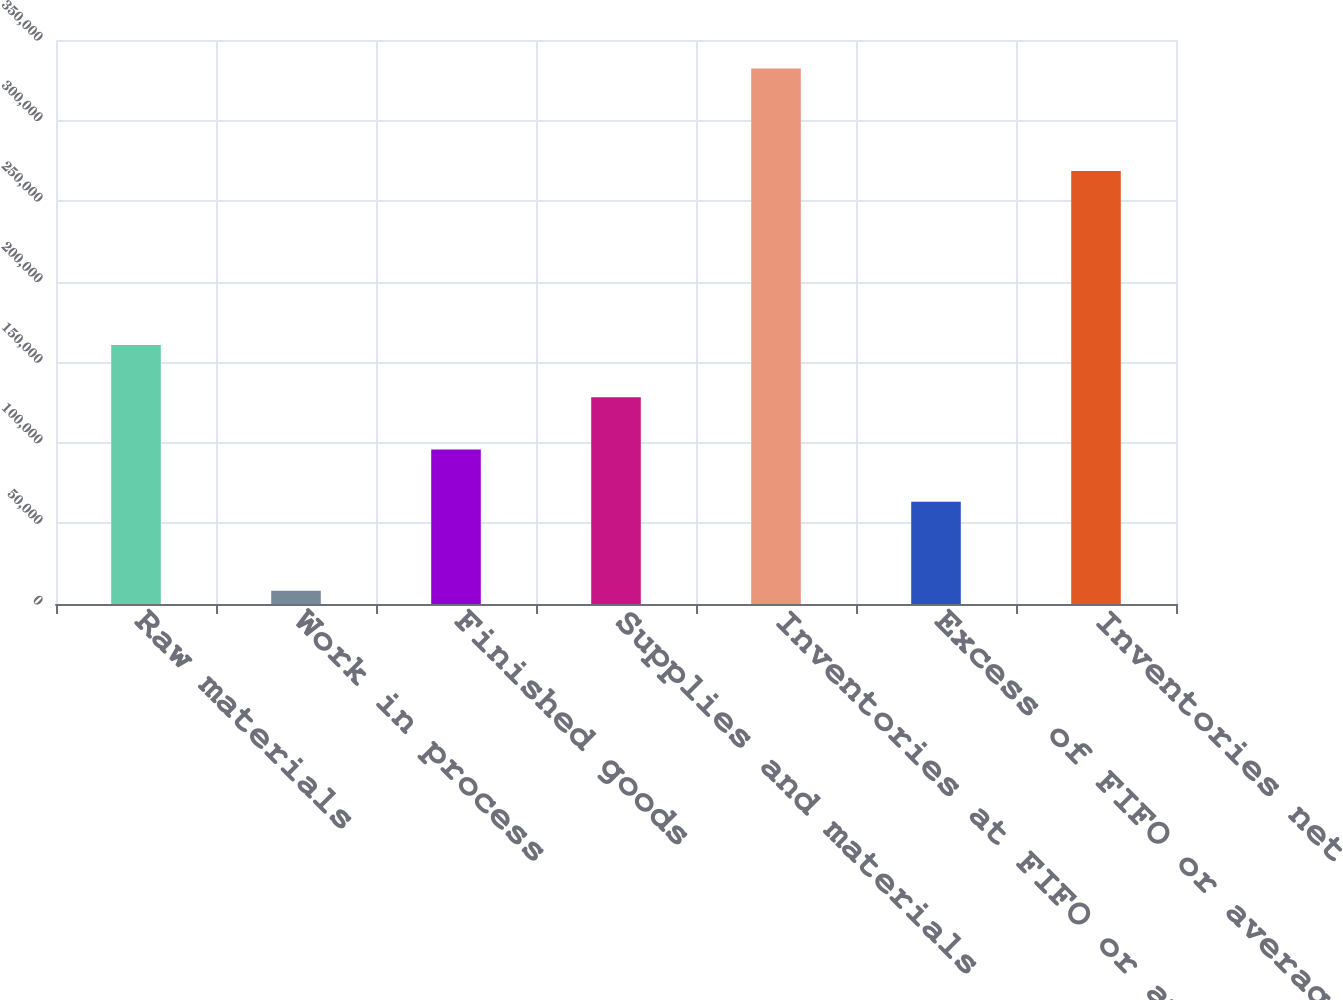<chart> <loc_0><loc_0><loc_500><loc_500><bar_chart><fcel>Raw materials<fcel>Work in process<fcel>Finished goods<fcel>Supplies and materials<fcel>Inventories at FIFO or average<fcel>Excess of FIFO or average cost<fcel>Inventories net<nl><fcel>160695<fcel>8287<fcel>95899.1<fcel>128297<fcel>332268<fcel>63501<fcel>268767<nl></chart> 